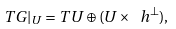<formula> <loc_0><loc_0><loc_500><loc_500>T G | _ { U } = T U \oplus ( U \times \ h ^ { \perp } ) ,</formula> 